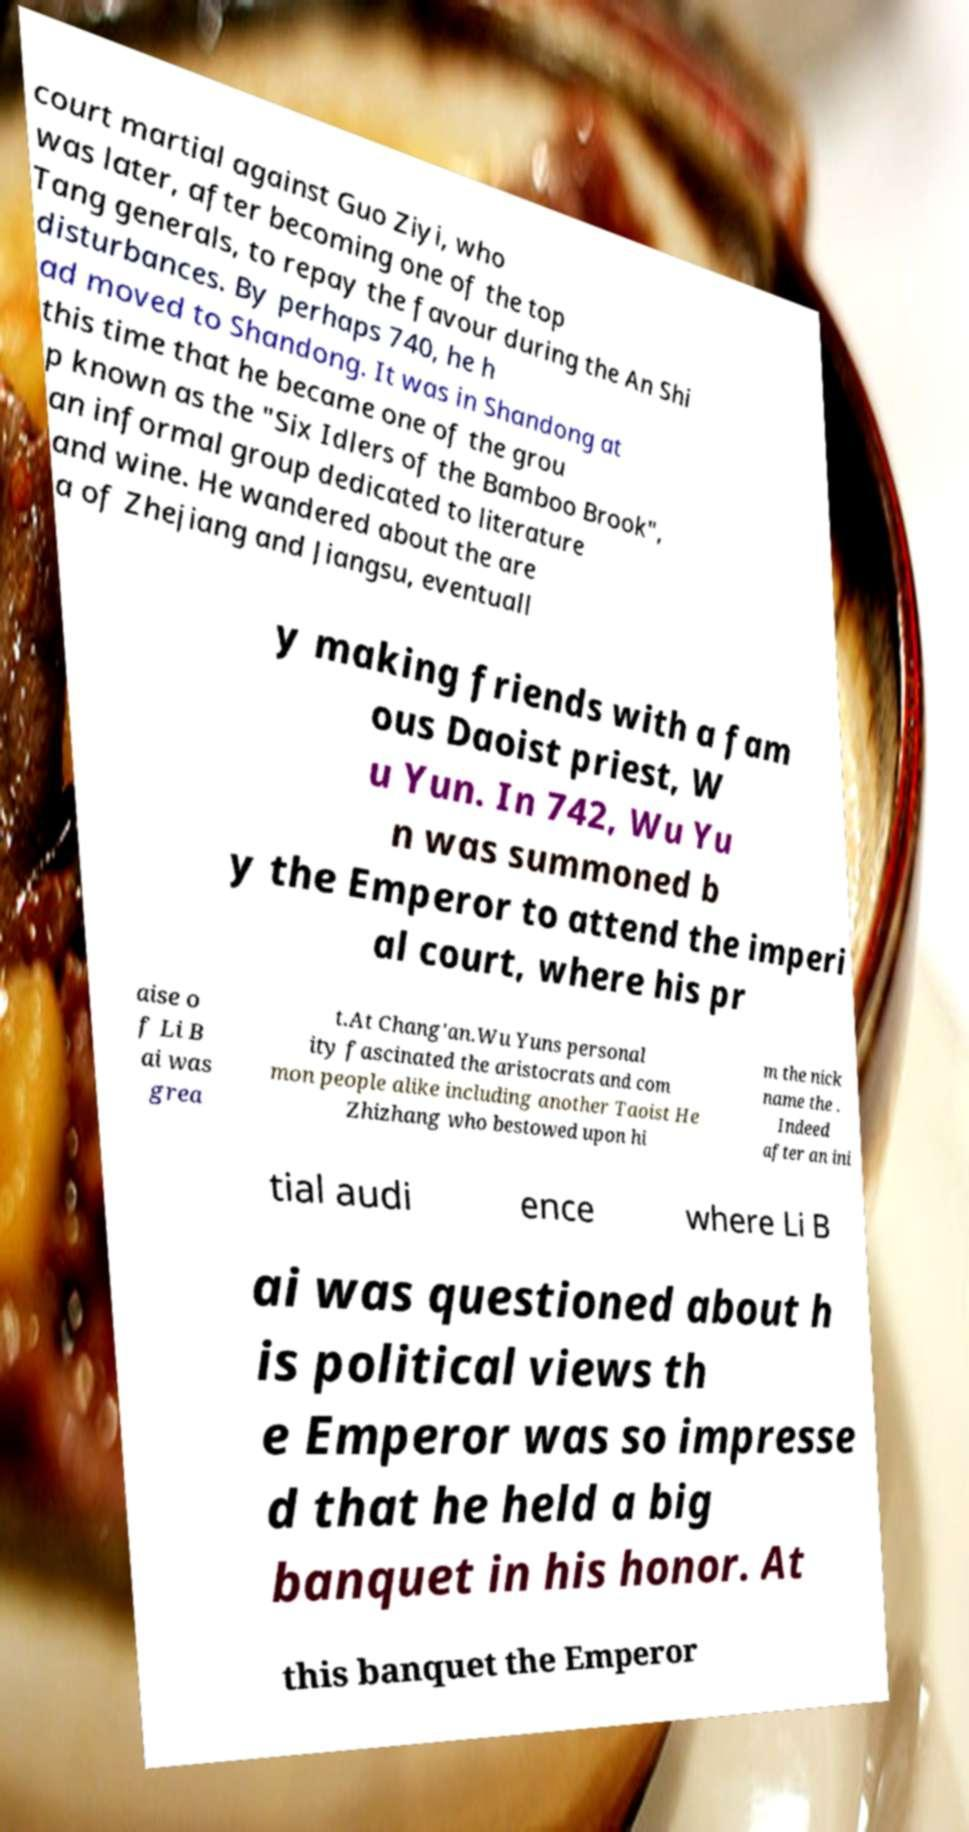Can you accurately transcribe the text from the provided image for me? court martial against Guo Ziyi, who was later, after becoming one of the top Tang generals, to repay the favour during the An Shi disturbances. By perhaps 740, he h ad moved to Shandong. It was in Shandong at this time that he became one of the grou p known as the "Six Idlers of the Bamboo Brook", an informal group dedicated to literature and wine. He wandered about the are a of Zhejiang and Jiangsu, eventuall y making friends with a fam ous Daoist priest, W u Yun. In 742, Wu Yu n was summoned b y the Emperor to attend the imperi al court, where his pr aise o f Li B ai was grea t.At Chang'an.Wu Yuns personal ity fascinated the aristocrats and com mon people alike including another Taoist He Zhizhang who bestowed upon hi m the nick name the . Indeed after an ini tial audi ence where Li B ai was questioned about h is political views th e Emperor was so impresse d that he held a big banquet in his honor. At this banquet the Emperor 